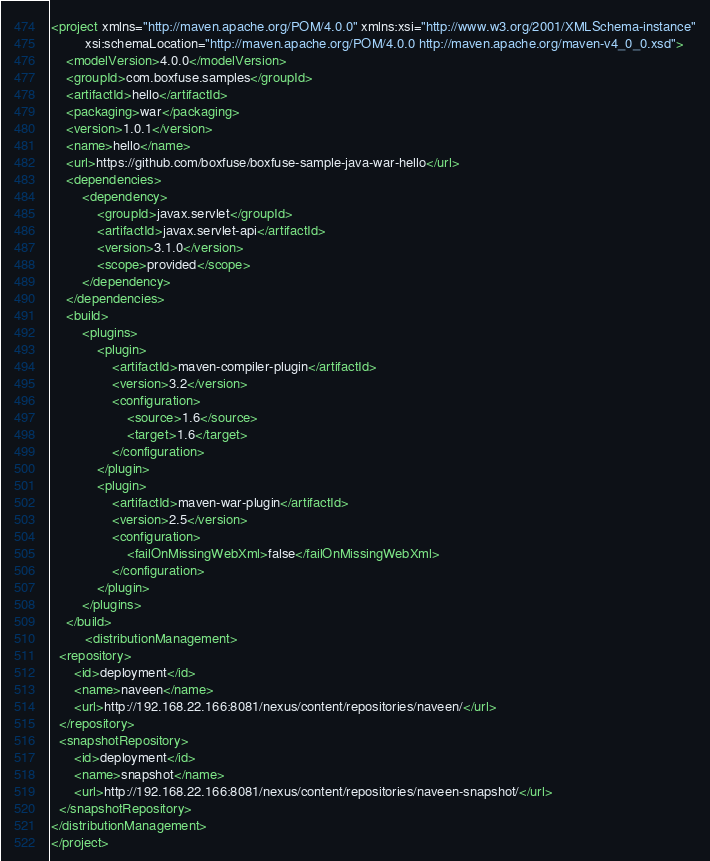Convert code to text. <code><loc_0><loc_0><loc_500><loc_500><_XML_><project xmlns="http://maven.apache.org/POM/4.0.0" xmlns:xsi="http://www.w3.org/2001/XMLSchema-instance"
         xsi:schemaLocation="http://maven.apache.org/POM/4.0.0 http://maven.apache.org/maven-v4_0_0.xsd">
    <modelVersion>4.0.0</modelVersion>
    <groupId>com.boxfuse.samples</groupId>
    <artifactId>hello</artifactId>
    <packaging>war</packaging>
    <version>1.0.1</version>
    <name>hello</name>
    <url>https://github.com/boxfuse/boxfuse-sample-java-war-hello</url>
    <dependencies>
        <dependency>
            <groupId>javax.servlet</groupId>
            <artifactId>javax.servlet-api</artifactId>
            <version>3.1.0</version>
            <scope>provided</scope>
        </dependency>
    </dependencies>
    <build>
        <plugins>
            <plugin>
                <artifactId>maven-compiler-plugin</artifactId>
                <version>3.2</version>
                <configuration>
                    <source>1.6</source>
                    <target>1.6</target>
                </configuration>
            </plugin>
            <plugin>
                <artifactId>maven-war-plugin</artifactId>
                <version>2.5</version>
                <configuration>
                    <failOnMissingWebXml>false</failOnMissingWebXml>
                </configuration>
            </plugin>
        </plugins>
    </build>
         <distributionManagement>
  <repository>
      <id>deployment</id>
      <name>naveen</name>
      <url>http://192.168.22.166:8081/nexus/content/repositories/naveen/</url>
  </repository>
  <snapshotRepository>
      <id>deployment</id>
      <name>snapshot</name>
      <url>http://192.168.22.166:8081/nexus/content/repositories/naveen-snapshot/</url>
  </snapshotRepository>
</distributionManagement>
</project>
</code> 